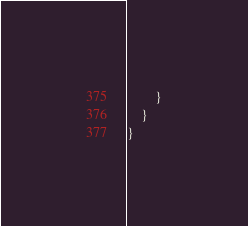Convert code to text. <code><loc_0><loc_0><loc_500><loc_500><_C_>		}
	}
}
</code> 